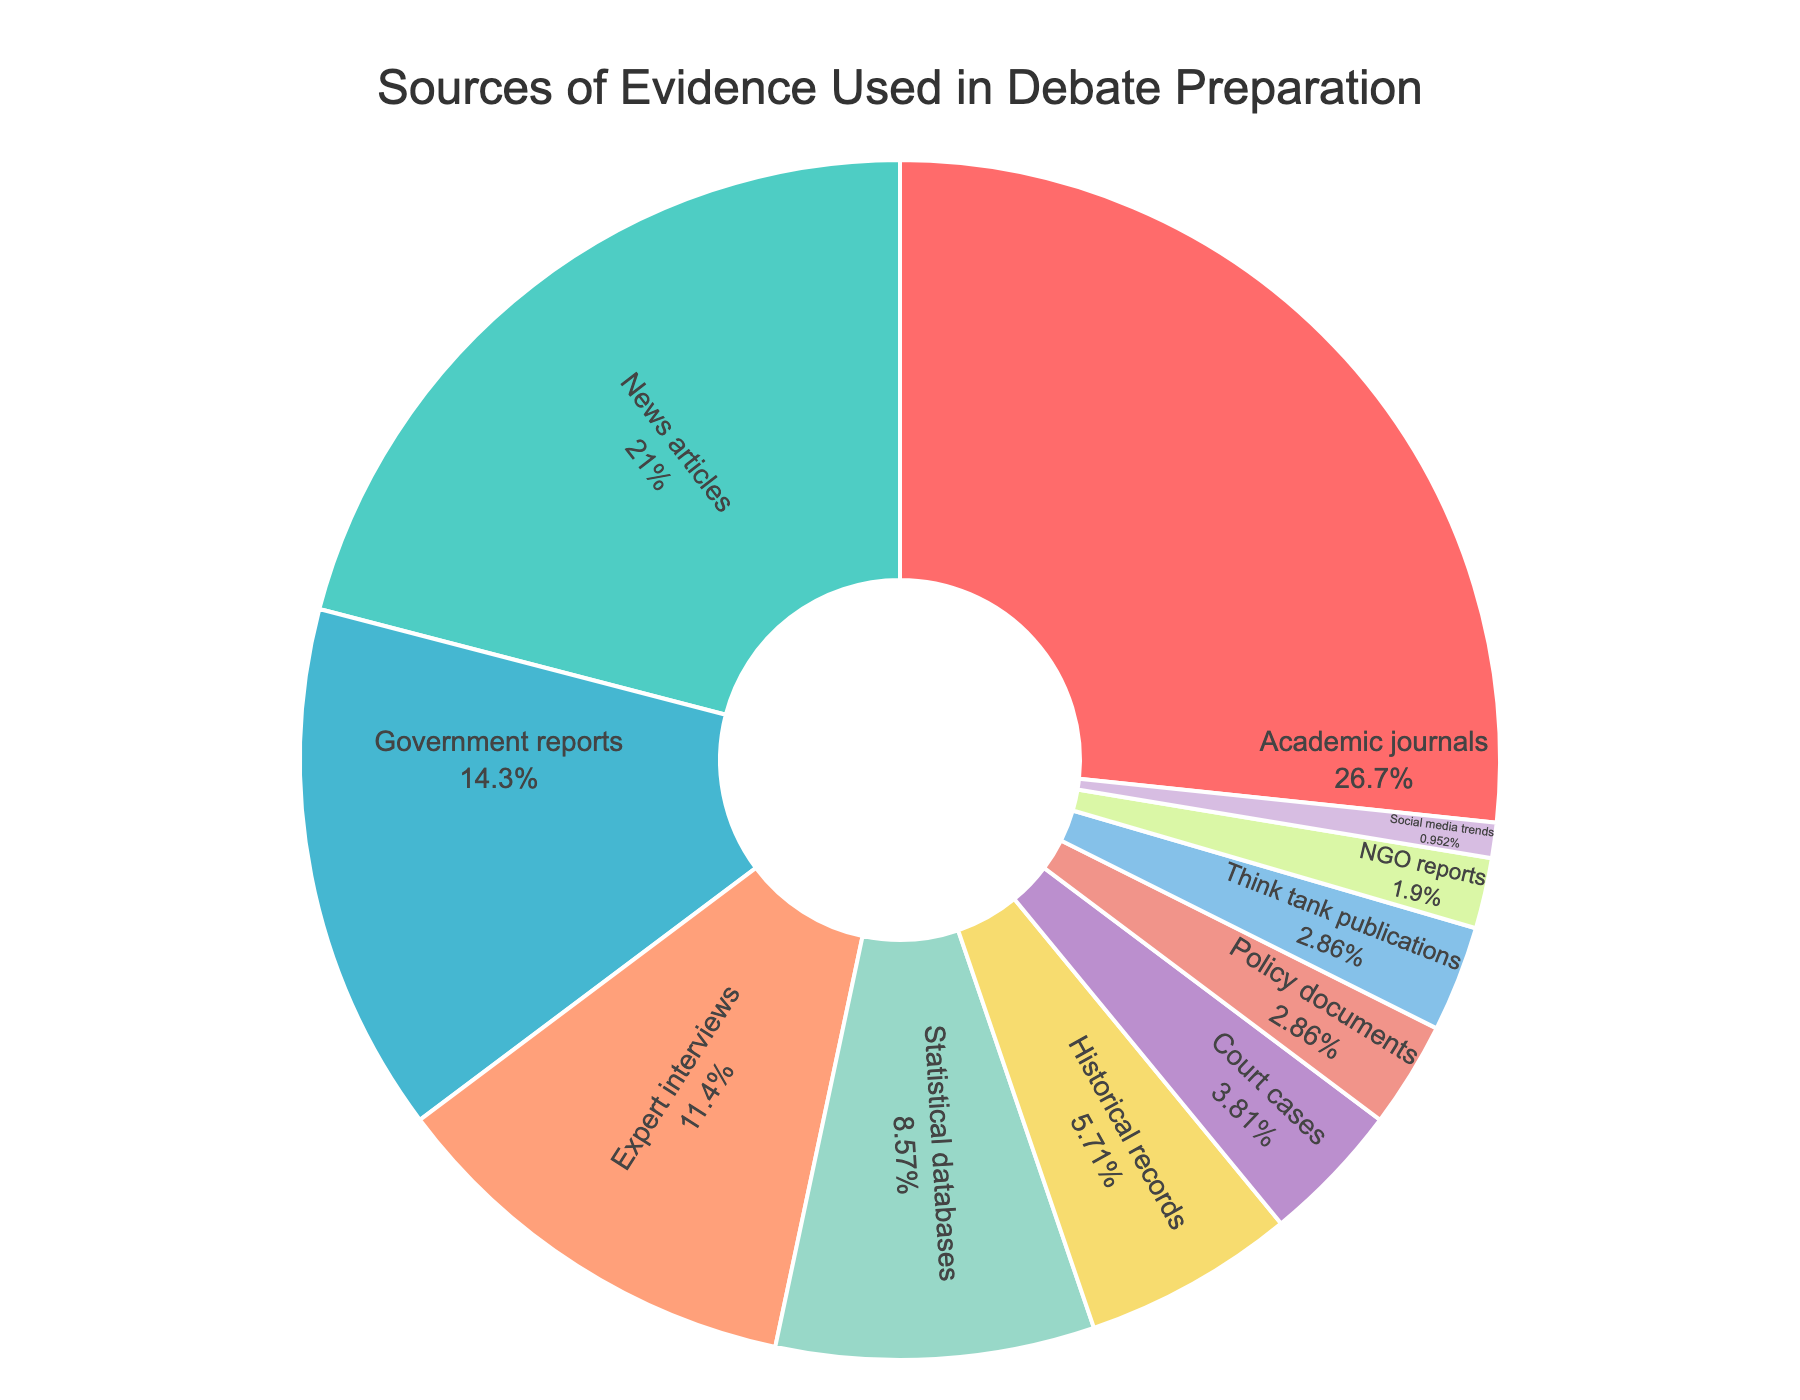What is the percentage of evidence sources that are academic journals? Referring to the section labeled "Academic journals" in the pie chart, note the percentage value given.
Answer: 28% Which source of evidence has the smallest percentage, and what is that percentage? Find the section with the smallest slice in the pie chart. The label for this section indicates the source type and its corresponding percentage.
Answer: Social media trends (1%) Combine the percentages of "Government reports" and "Expert interviews." What is their total? Identify the slices for "Government reports" (15%) and "Expert interviews" (12%). Add these percentages together: 15 + 12.
Answer: 27% Which source of evidence is utilized less: "News articles" or "Expert interviews"? Compare the percentage values of "News articles" (22%) and "Expert interviews" (12%).
Answer: Expert interviews What color is the segment representing "News articles"? Look for the segment labeled "News articles" and describe its color.
Answer: Green What is the combined percentage of "NGO reports," "Policy documents," and "Think tank publications"? Identify and sum the percentages for "NGO reports" (2%), "Policy documents" (3%), and "Think tank publications" (3%): 2 + 3 + 3.
Answer: 8% Is the percentage of evidence from "Statistical databases" greater than that from "Historical records"? If so, by how much? Compare the percentage of "Statistical databases" (9%) with "Historical records" (6%). Subtract the smaller percentage from the larger: 9 - 6.
Answer: Yes, by 3% What is the total percentage for all sources that individually contribute less than 10%? Sum the percentages of all sources less than 10%: "Statistical databases" (9%), "Historical records" (6%), "Court cases" (4%), "Policy documents" (3%), "Think tank publications" (3%), "NGO reports" (2%), "Social media trends" (1%): 9 + 6 + 4 + 3 + 3 + 2 + 1.
Answer: 28% Are there more types of sources with a percentage of 3% or less, or more types with a percentage greater than 10%? Count the sources with 3% or less (Policy documents, Think tank publications, NGO reports, Social media trends: 4) and those greater than 10% (Academic journals, News articles, Government reports, Expert interviews: 4).
Answer: Equal Which source contributes 6% to the evidence used in debate preparation? Find the segment labeled with "6%".
Answer: Historical records 